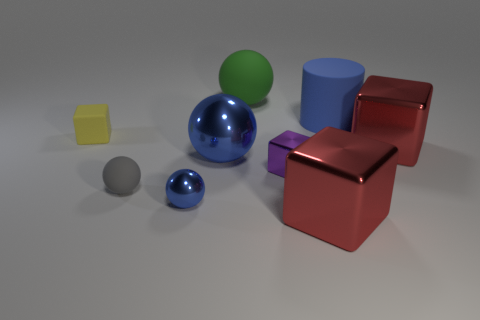Add 1 small yellow rubber cubes. How many objects exist? 10 Subtract all balls. How many objects are left? 5 Add 5 small shiny spheres. How many small shiny spheres exist? 6 Subtract 0 red cylinders. How many objects are left? 9 Subtract all tiny yellow matte objects. Subtract all tiny objects. How many objects are left? 4 Add 9 big cylinders. How many big cylinders are left? 10 